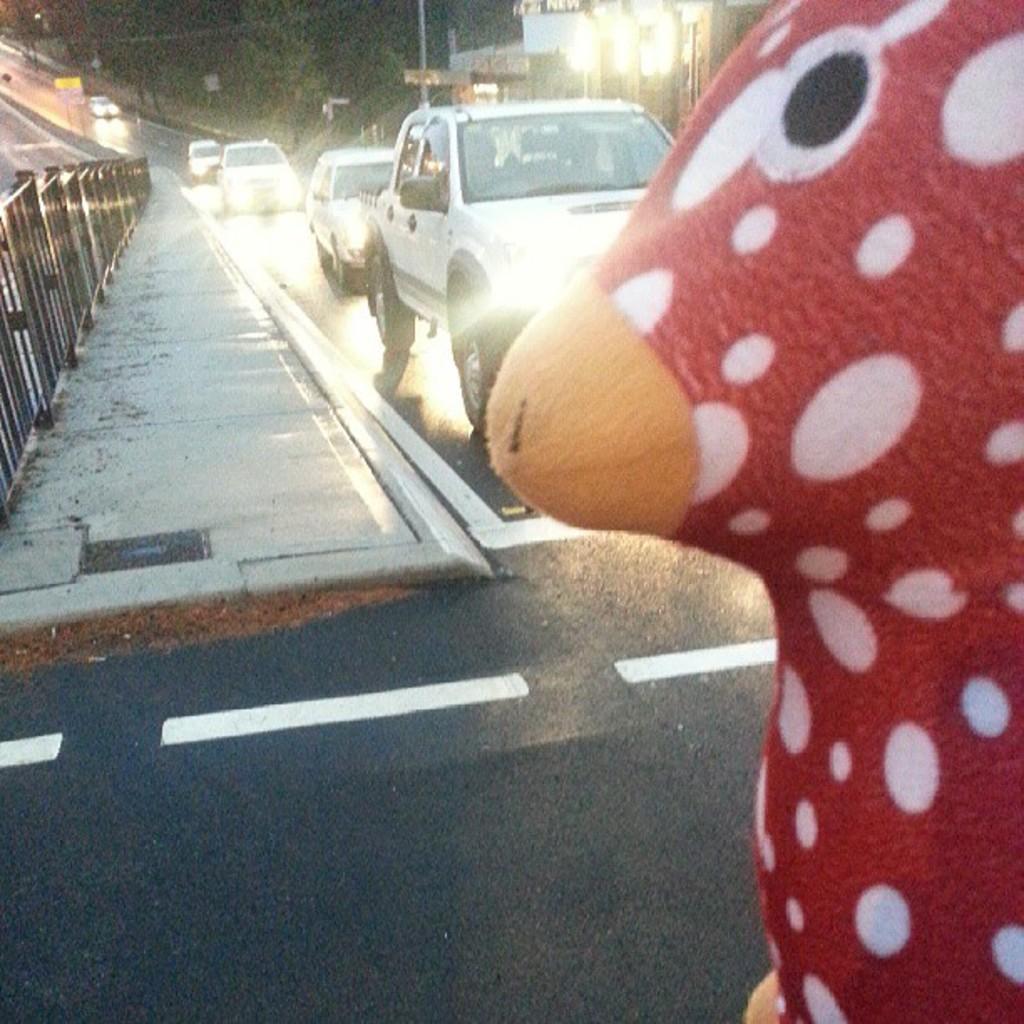In one or two sentences, can you explain what this image depicts? On the right side we can see a object with red color. On that there are white spots. In the back there are vehicles on the road. On the left side there is a sidewalk with railings. In the back there are trees. Also there are lights. And there is a road at the bottom. 